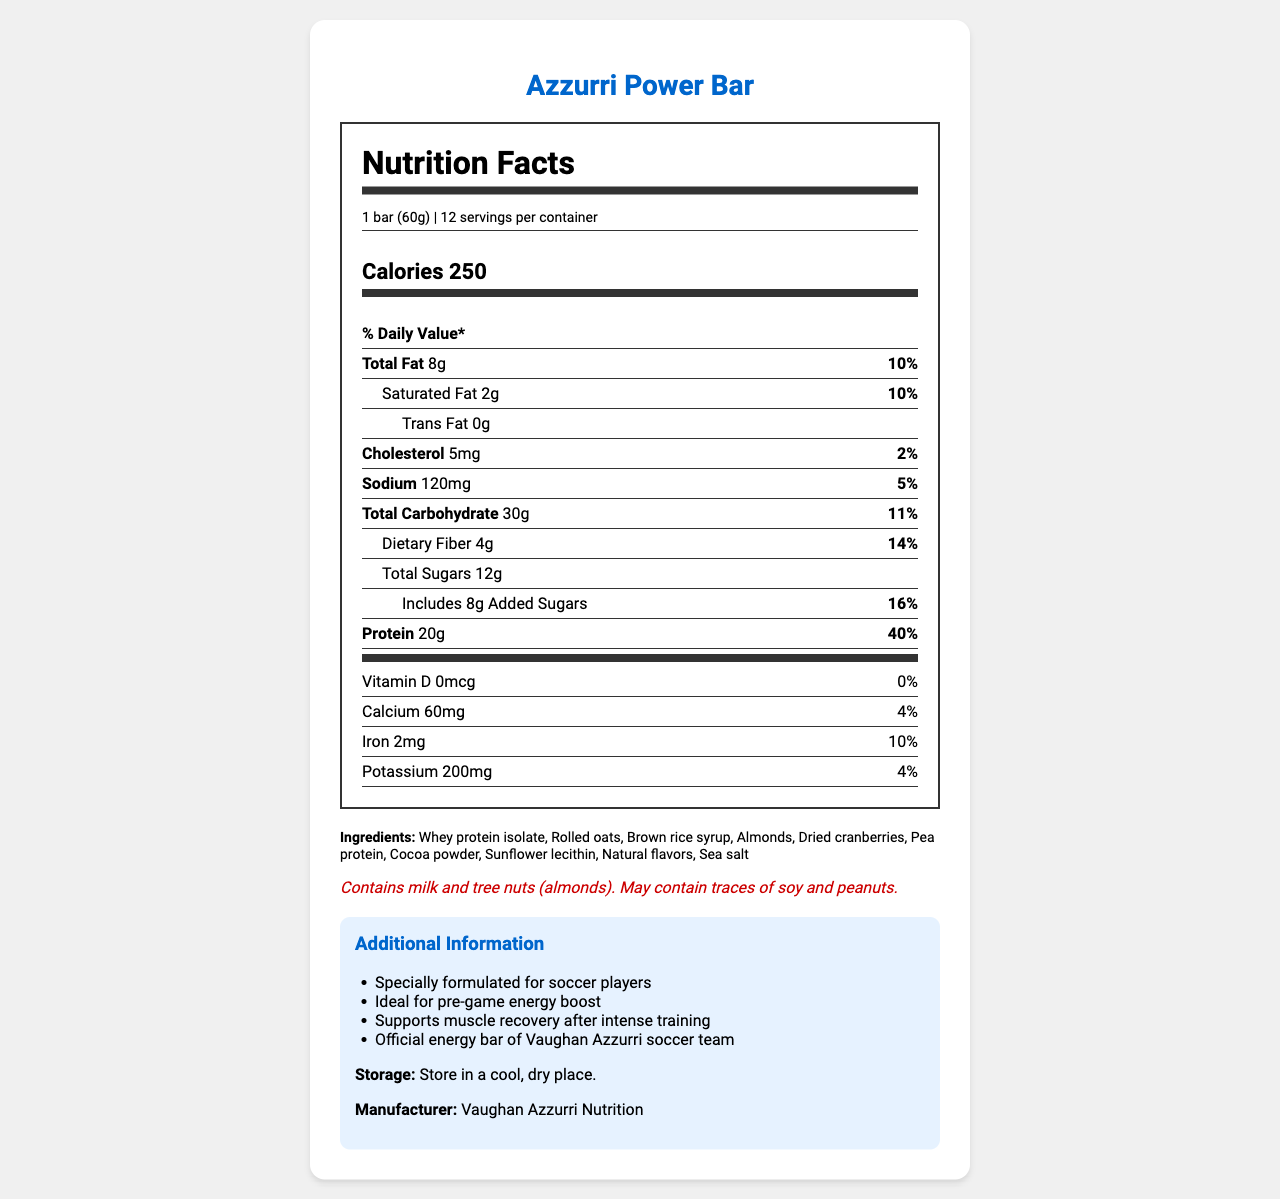what is the serving size for the Azzurri Power Bar? The serving size is explicitly mentioned in the nutrition facts section of the document.
Answer: 1 bar (60g) how many calories does one Azzurri Power Bar contain? The calorie content per serving is listed prominently in the nutrition facts section.
Answer: 250 calories what is the amount of protein per serving in the Azzurri Power Bar? The protein content is mentioned under the nutrient info section.
Answer: 20g what is the daily value percentage for saturated fat? The daily value percentage for saturated fat is listed next to its amount (2g) in the nutrient info.
Answer: 10% which ingredient is not present in the Azzurri Power Bar? A. Whey protein isolate B. Rolled oats C. Peanuts The list of ingredients includes whey protein isolate, rolled oats, etc., but not peanuts.
Answer: C how much dietary fiber does one Azzurri Power Bar contain? Dietary fiber content is listed under the total carbohydrate section.
Answer: 4g is the Azzurri Power Bar suitable for people with peanut allergies? The allergen info specifies that it may contain traces of peanuts.
Answer: No what is the daily value percentage for calcium in the Azzurri Power Bar? The daily value percentage for calcium is provided under the vitamins section.
Answer: 4% how many servings are there per container of Azzurri Power Bar? This information is specified in the serving info section.
Answer: 12 servings what is the main purpose of the Azzurri Power Bar? The additional information notes that it is designed for soccer players, providing pre-game energy and supporting muscle recovery.
Answer: Specially formulated for soccer players what is the amount of added sugars in one Azzurri Power Bar? The amount of added sugars is listed under the total sugars section.
Answer: 8g does the Azzurri Power Bar contain any trans fat? The nutrient info clearly states that trans fat content is 0g.
Answer: No which of the following is the official energy bar of Vaughan Azzurri soccer team? I. Azzurri Power Bar II. Super Soccer Bar III. Energy Boost Bar The additional information confirms that Azzurri Power Bar is the official energy bar.
Answer: I how should the Azzurri Power Bar be stored? The storage instructions explicitly mention storing in a cool, dry place.
Answer: In a cool, dry place does the Azzurri Power Bar contain Vitamin D? The Vitamin D content is listed as 0mcg in the vitamins section.
Answer: No who is the manufacturer of the Azzurri Power Bar? The manufacturer is identified in the additional information section.
Answer: Vaughan Azzurri Nutrition summarize the main idea of the document. The document provides comprehensive information about the Azzurri Power Bar, including its nutritional content, ingredients, potential allergens, storage requirements, and its suitability for soccer players, emphasizing its role in energy supply and muscle recovery.
Answer: The document outlines the nutritional information, ingredients, allergen info, storage instructions, and additional details for the Azzurri Power Bar, a protein-packed energy bar designed specifically for soccer players. what is the price of one Azzurri Power Bar? The document does not include any pricing information for the Azzurri Power Bar.
Answer: Not enough information 